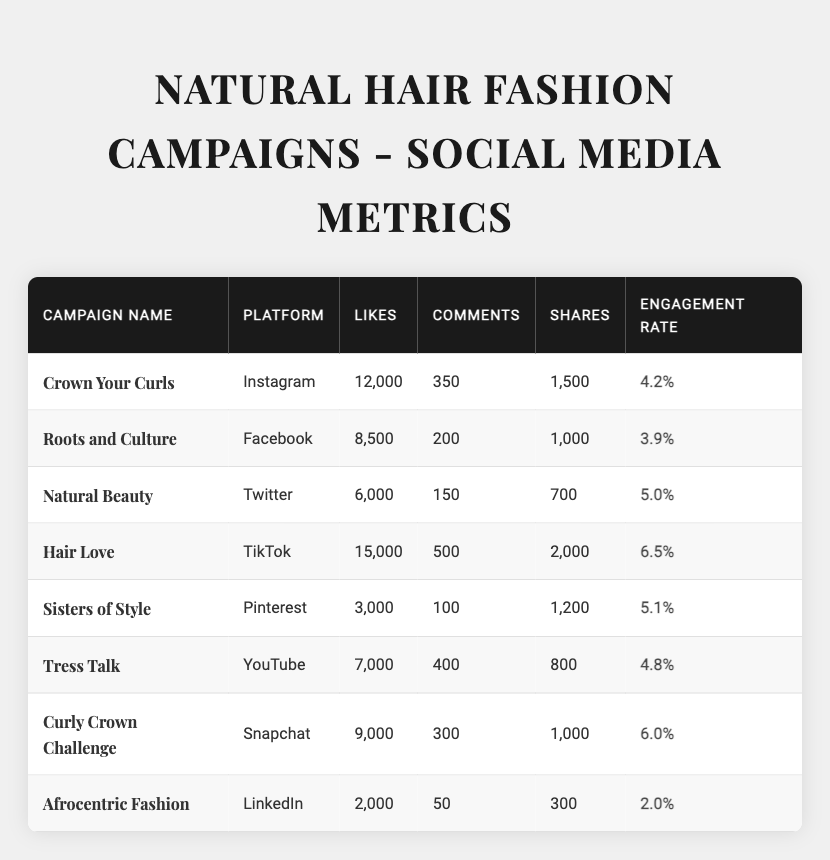What is the engagement rate of the "Hair Love" campaign? The engagement rate for the "Hair Love" campaign is listed in the table under the "Engagement Rate" column for this specific campaign, which is 6.5%.
Answer: 6.5% Which platform had the highest number of likes for a campaign? In the table, the highest number of likes is 15,000, associated with the "Hair Love" campaign on TikTok.
Answer: TikTok What is the total number of comments across all campaigns? To find the total number of comments, sum the comments from each campaign: 350 + 200 + 150 + 500 + 100 + 400 + 300 + 50 = 2050.
Answer: 2050 Did the "Roots and Culture" campaign have more shares than the "Natural Beauty" campaign? The "Roots and Culture" campaign had 1,000 shares while the "Natural Beauty" campaign had 700 shares. Comparing the two, 1,000 is greater than 700, so the statement is true.
Answer: Yes What is the average engagement rate across all campaigns? To find the average engagement rate, first convert each percentage into a decimal: 0.042, 0.039, 0.050, 0.065, 0.051, 0.048, 0.060, 0.020. Next, sum them up: 0.042 + 0.039 + 0.050 + 0.065 + 0.051 + 0.048 + 0.060 + 0.020 = 0.375. Then, divide by the number of campaigns (8), which gives 0.375 / 8 = 0.046875, or 4.69% when converted back to percentage.
Answer: 4.69% Which campaign had the least likes, and what was its engagement rate? By reviewing the "Likes" column, the campaign with the least likes is "Afrocentric Fashion" with 2,000 likes. Its engagement rate, listed alongside, is 2.0%.
Answer: Afrocentric Fashion, 2.0% Which two campaigns had similar engagement rates, and what are they? The engagement rates for "Natural Beauty" (5.0%) and "Sisters of Style" (5.1%) are close but "Sisters of Style" is slightly higher. Additionally, we can compare "Curly Crown Challenge" (6.0%) and "Hair Love" (6.5%) as well.
Answer: Natural Beauty and Sisters of Style What is the difference in likes between the highest and lowest campaigns? The highest likes come from "Hair Love" with 15,000 likes, while the lowest likes come from "Afrocentric Fashion" with 2,000 likes. The difference is 15,000 - 2,000 = 13,000.
Answer: 13,000 Which platform had the least engagement for its campaign, and what was the engagement rate? The platform with the least engagement is LinkedIn, belonging to "Afrocentric Fashion" campaign with an engagement rate of 2.0%.
Answer: LinkedIn, 2.0% Did any campaign achieve more than 1,500 shares? By checking the "Shares" column, "Hair Love" (2,000 shares) and "Crown Your Curls" (1,500 shares) both achieved 1,500 or more shares, confirming this is true for both campaigns.
Answer: Yes 